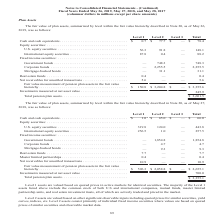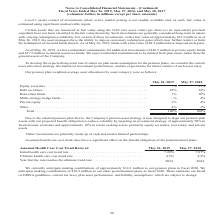According to Conagra Brands's financial document, What are Level 1 assets valued based on? quoted prices in active markets for identical securities. The document states: "Level 1 assets are valued based on quoted prices in active markets for identical securities. The majority of the Level 1..." Also, How much was the total pension plan assets (in millions) as of May 26, 2019? According to the financial document, $3,601.5. The relevant text states: "Total pension plan assets. . $ 3,601.5..." Also, How much were the fair values of Level 1 and 2 cash and cash equivalents assets, respectively? The document shows two values: $0.7 and $77.7 (in millions). From the document: "Cash and cash equivalents . $ 0.7 $ 77.7 $ — $ 78.4 Cash and cash equivalents . $ 0.7 $ 77.7 $ — $ 78.4..." Also, can you calculate: What is the proportion of total fixed income securities over total pension plan assets? To answer this question, I need to perform calculations using the financial data. The calculation is: (748.3+2,255.5+31.1)/3,601.5 , which equals 0.84. This is based on the information: "Government bonds . — 748.3 — 748.3 Corporate bonds . — 2,255.5 — 2,255.5 Total pension plan assets. . $ 3,601.5 Mortgage-backed bonds . — 31.1 — 31.1..." The key data points involved are: 2,255.5, 3,601.5, 31.1. Also, can you calculate: What is the ratio of Level 1 assets to Level 2 assets? Based on the calculation: 150.8/3,204.8 , the result is 0.05. This is based on the information: "nsion plan assets in the fair value hierarchy . $ 150.8 $ 3,204.8 $ — $ 3,355.6 an assets in the fair value hierarchy . $ 150.8 $ 3,204.8 $ — $ 3,355.6..." The key data points involved are: 150.8, 3,204.8. Also, can you calculate: What is the ratio (in percentage) of the fair value of the customary redemption gates over total pension plan assets as of May 26, 2019? Based on the calculation: 4.2 / 3,601.5 , the result is 0.12 (percentage). This is based on the information: "Total pension plan assets. . $ 3,601.5 . As of May 26, 2019, funds with a fair value of $4.2 million have imposed such gates...." The key data points involved are: 3,601.5, 4.2. 